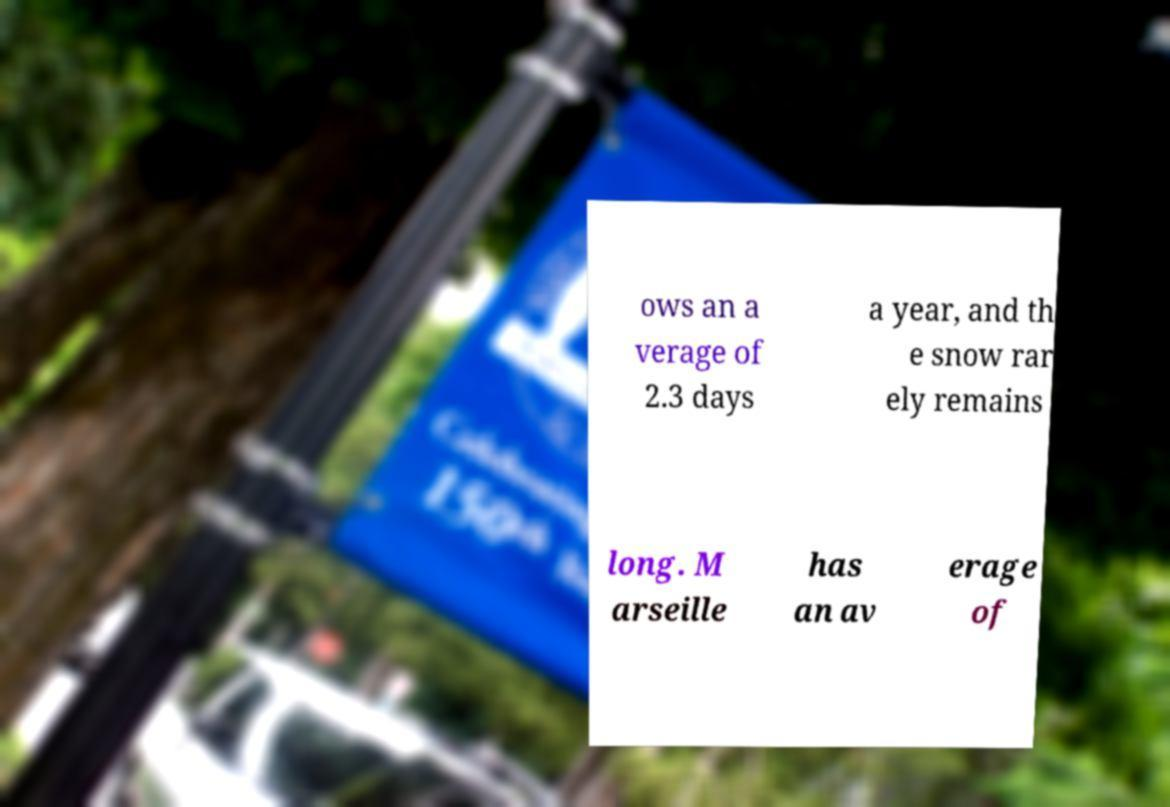Please read and relay the text visible in this image. What does it say? ows an a verage of 2.3 days a year, and th e snow rar ely remains long. M arseille has an av erage of 